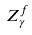Convert formula to latex. <formula><loc_0><loc_0><loc_500><loc_500>Z _ { \gamma } ^ { f }</formula> 